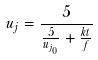<formula> <loc_0><loc_0><loc_500><loc_500>u _ { j } = \frac { 5 } { \frac { 5 } { u _ { j _ { 0 } } } + \frac { k t } { f } }</formula> 